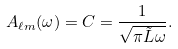Convert formula to latex. <formula><loc_0><loc_0><loc_500><loc_500>A _ { \ell m } ( \omega ) = C = \frac { 1 } { \sqrt { \pi \tilde { L } \omega } } .</formula> 